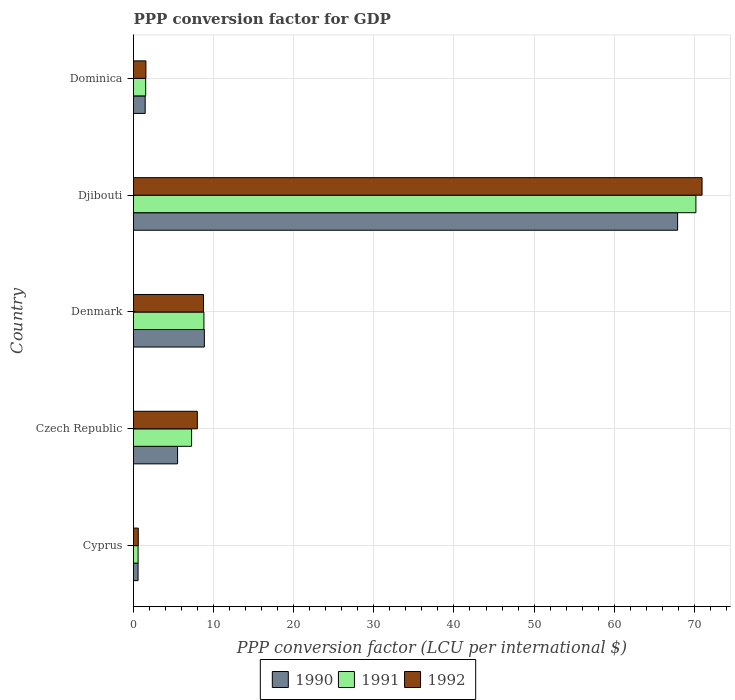How many groups of bars are there?
Offer a very short reply. 5. How many bars are there on the 1st tick from the top?
Offer a very short reply. 3. What is the label of the 1st group of bars from the top?
Make the answer very short. Dominica. In how many cases, is the number of bars for a given country not equal to the number of legend labels?
Make the answer very short. 0. What is the PPP conversion factor for GDP in 1992 in Denmark?
Provide a short and direct response. 8.74. Across all countries, what is the maximum PPP conversion factor for GDP in 1992?
Keep it short and to the point. 70.97. Across all countries, what is the minimum PPP conversion factor for GDP in 1990?
Your answer should be compact. 0.57. In which country was the PPP conversion factor for GDP in 1990 maximum?
Keep it short and to the point. Djibouti. In which country was the PPP conversion factor for GDP in 1992 minimum?
Give a very brief answer. Cyprus. What is the total PPP conversion factor for GDP in 1990 in the graph?
Give a very brief answer. 84.29. What is the difference between the PPP conversion factor for GDP in 1991 in Denmark and that in Dominica?
Offer a terse response. 7.27. What is the difference between the PPP conversion factor for GDP in 1990 in Denmark and the PPP conversion factor for GDP in 1991 in Djibouti?
Keep it short and to the point. -61.36. What is the average PPP conversion factor for GDP in 1991 per country?
Give a very brief answer. 17.67. What is the difference between the PPP conversion factor for GDP in 1990 and PPP conversion factor for GDP in 1991 in Czech Republic?
Provide a succinct answer. -1.75. In how many countries, is the PPP conversion factor for GDP in 1992 greater than 6 LCU?
Provide a short and direct response. 3. What is the ratio of the PPP conversion factor for GDP in 1990 in Cyprus to that in Djibouti?
Ensure brevity in your answer.  0.01. Is the PPP conversion factor for GDP in 1992 in Cyprus less than that in Denmark?
Your answer should be very brief. Yes. Is the difference between the PPP conversion factor for GDP in 1990 in Denmark and Dominica greater than the difference between the PPP conversion factor for GDP in 1991 in Denmark and Dominica?
Provide a succinct answer. Yes. What is the difference between the highest and the second highest PPP conversion factor for GDP in 1990?
Provide a short and direct response. 59.08. What is the difference between the highest and the lowest PPP conversion factor for GDP in 1991?
Your answer should be very brief. 69.63. Is the sum of the PPP conversion factor for GDP in 1992 in Czech Republic and Dominica greater than the maximum PPP conversion factor for GDP in 1990 across all countries?
Your answer should be compact. No. What does the 1st bar from the top in Dominica represents?
Provide a succinct answer. 1992. What does the 1st bar from the bottom in Cyprus represents?
Your response must be concise. 1990. Is it the case that in every country, the sum of the PPP conversion factor for GDP in 1990 and PPP conversion factor for GDP in 1991 is greater than the PPP conversion factor for GDP in 1992?
Keep it short and to the point. Yes. How many bars are there?
Give a very brief answer. 15. Are all the bars in the graph horizontal?
Provide a short and direct response. Yes. Where does the legend appear in the graph?
Give a very brief answer. Bottom center. How many legend labels are there?
Provide a succinct answer. 3. How are the legend labels stacked?
Your answer should be very brief. Horizontal. What is the title of the graph?
Make the answer very short. PPP conversion factor for GDP. Does "1972" appear as one of the legend labels in the graph?
Provide a succinct answer. No. What is the label or title of the X-axis?
Make the answer very short. PPP conversion factor (LCU per international $). What is the label or title of the Y-axis?
Offer a terse response. Country. What is the PPP conversion factor (LCU per international $) in 1990 in Cyprus?
Offer a terse response. 0.57. What is the PPP conversion factor (LCU per international $) of 1991 in Cyprus?
Make the answer very short. 0.57. What is the PPP conversion factor (LCU per international $) in 1992 in Cyprus?
Your answer should be very brief. 0.59. What is the PPP conversion factor (LCU per international $) of 1990 in Czech Republic?
Your answer should be compact. 5.5. What is the PPP conversion factor (LCU per international $) of 1991 in Czech Republic?
Offer a very short reply. 7.25. What is the PPP conversion factor (LCU per international $) in 1992 in Czech Republic?
Keep it short and to the point. 7.97. What is the PPP conversion factor (LCU per international $) of 1990 in Denmark?
Provide a short and direct response. 8.84. What is the PPP conversion factor (LCU per international $) of 1991 in Denmark?
Keep it short and to the point. 8.79. What is the PPP conversion factor (LCU per international $) in 1992 in Denmark?
Provide a short and direct response. 8.74. What is the PPP conversion factor (LCU per international $) in 1990 in Djibouti?
Give a very brief answer. 67.92. What is the PPP conversion factor (LCU per international $) of 1991 in Djibouti?
Give a very brief answer. 70.2. What is the PPP conversion factor (LCU per international $) of 1992 in Djibouti?
Keep it short and to the point. 70.97. What is the PPP conversion factor (LCU per international $) in 1990 in Dominica?
Your answer should be compact. 1.46. What is the PPP conversion factor (LCU per international $) of 1991 in Dominica?
Offer a very short reply. 1.52. What is the PPP conversion factor (LCU per international $) in 1992 in Dominica?
Your answer should be compact. 1.55. Across all countries, what is the maximum PPP conversion factor (LCU per international $) in 1990?
Offer a very short reply. 67.92. Across all countries, what is the maximum PPP conversion factor (LCU per international $) in 1991?
Offer a very short reply. 70.2. Across all countries, what is the maximum PPP conversion factor (LCU per international $) in 1992?
Your answer should be compact. 70.97. Across all countries, what is the minimum PPP conversion factor (LCU per international $) in 1990?
Provide a short and direct response. 0.57. Across all countries, what is the minimum PPP conversion factor (LCU per international $) in 1991?
Offer a terse response. 0.57. Across all countries, what is the minimum PPP conversion factor (LCU per international $) in 1992?
Ensure brevity in your answer.  0.59. What is the total PPP conversion factor (LCU per international $) in 1990 in the graph?
Provide a succinct answer. 84.29. What is the total PPP conversion factor (LCU per international $) in 1991 in the graph?
Make the answer very short. 88.34. What is the total PPP conversion factor (LCU per international $) of 1992 in the graph?
Your answer should be very brief. 89.82. What is the difference between the PPP conversion factor (LCU per international $) of 1990 in Cyprus and that in Czech Republic?
Your answer should be very brief. -4.93. What is the difference between the PPP conversion factor (LCU per international $) in 1991 in Cyprus and that in Czech Republic?
Offer a very short reply. -6.68. What is the difference between the PPP conversion factor (LCU per international $) in 1992 in Cyprus and that in Czech Republic?
Your answer should be compact. -7.37. What is the difference between the PPP conversion factor (LCU per international $) in 1990 in Cyprus and that in Denmark?
Give a very brief answer. -8.27. What is the difference between the PPP conversion factor (LCU per international $) in 1991 in Cyprus and that in Denmark?
Provide a succinct answer. -8.22. What is the difference between the PPP conversion factor (LCU per international $) in 1992 in Cyprus and that in Denmark?
Keep it short and to the point. -8.14. What is the difference between the PPP conversion factor (LCU per international $) in 1990 in Cyprus and that in Djibouti?
Offer a very short reply. -67.35. What is the difference between the PPP conversion factor (LCU per international $) in 1991 in Cyprus and that in Djibouti?
Provide a short and direct response. -69.63. What is the difference between the PPP conversion factor (LCU per international $) of 1992 in Cyprus and that in Djibouti?
Provide a succinct answer. -70.38. What is the difference between the PPP conversion factor (LCU per international $) in 1990 in Cyprus and that in Dominica?
Your response must be concise. -0.89. What is the difference between the PPP conversion factor (LCU per international $) in 1991 in Cyprus and that in Dominica?
Your response must be concise. -0.95. What is the difference between the PPP conversion factor (LCU per international $) of 1992 in Cyprus and that in Dominica?
Give a very brief answer. -0.95. What is the difference between the PPP conversion factor (LCU per international $) in 1990 in Czech Republic and that in Denmark?
Offer a terse response. -3.34. What is the difference between the PPP conversion factor (LCU per international $) of 1991 in Czech Republic and that in Denmark?
Make the answer very short. -1.54. What is the difference between the PPP conversion factor (LCU per international $) in 1992 in Czech Republic and that in Denmark?
Keep it short and to the point. -0.77. What is the difference between the PPP conversion factor (LCU per international $) in 1990 in Czech Republic and that in Djibouti?
Give a very brief answer. -62.42. What is the difference between the PPP conversion factor (LCU per international $) of 1991 in Czech Republic and that in Djibouti?
Your response must be concise. -62.95. What is the difference between the PPP conversion factor (LCU per international $) in 1992 in Czech Republic and that in Djibouti?
Your answer should be very brief. -63. What is the difference between the PPP conversion factor (LCU per international $) in 1990 in Czech Republic and that in Dominica?
Give a very brief answer. 4.04. What is the difference between the PPP conversion factor (LCU per international $) in 1991 in Czech Republic and that in Dominica?
Your answer should be compact. 5.73. What is the difference between the PPP conversion factor (LCU per international $) of 1992 in Czech Republic and that in Dominica?
Your answer should be compact. 6.42. What is the difference between the PPP conversion factor (LCU per international $) of 1990 in Denmark and that in Djibouti?
Your response must be concise. -59.08. What is the difference between the PPP conversion factor (LCU per international $) in 1991 in Denmark and that in Djibouti?
Your response must be concise. -61.41. What is the difference between the PPP conversion factor (LCU per international $) in 1992 in Denmark and that in Djibouti?
Make the answer very short. -62.23. What is the difference between the PPP conversion factor (LCU per international $) of 1990 in Denmark and that in Dominica?
Keep it short and to the point. 7.39. What is the difference between the PPP conversion factor (LCU per international $) of 1991 in Denmark and that in Dominica?
Offer a terse response. 7.27. What is the difference between the PPP conversion factor (LCU per international $) in 1992 in Denmark and that in Dominica?
Your answer should be compact. 7.19. What is the difference between the PPP conversion factor (LCU per international $) in 1990 in Djibouti and that in Dominica?
Make the answer very short. 66.46. What is the difference between the PPP conversion factor (LCU per international $) of 1991 in Djibouti and that in Dominica?
Your answer should be compact. 68.68. What is the difference between the PPP conversion factor (LCU per international $) in 1992 in Djibouti and that in Dominica?
Your answer should be compact. 69.42. What is the difference between the PPP conversion factor (LCU per international $) in 1990 in Cyprus and the PPP conversion factor (LCU per international $) in 1991 in Czech Republic?
Keep it short and to the point. -6.68. What is the difference between the PPP conversion factor (LCU per international $) of 1990 in Cyprus and the PPP conversion factor (LCU per international $) of 1992 in Czech Republic?
Offer a terse response. -7.4. What is the difference between the PPP conversion factor (LCU per international $) in 1991 in Cyprus and the PPP conversion factor (LCU per international $) in 1992 in Czech Republic?
Provide a succinct answer. -7.39. What is the difference between the PPP conversion factor (LCU per international $) in 1990 in Cyprus and the PPP conversion factor (LCU per international $) in 1991 in Denmark?
Offer a terse response. -8.22. What is the difference between the PPP conversion factor (LCU per international $) in 1990 in Cyprus and the PPP conversion factor (LCU per international $) in 1992 in Denmark?
Your response must be concise. -8.17. What is the difference between the PPP conversion factor (LCU per international $) in 1991 in Cyprus and the PPP conversion factor (LCU per international $) in 1992 in Denmark?
Your answer should be very brief. -8.16. What is the difference between the PPP conversion factor (LCU per international $) of 1990 in Cyprus and the PPP conversion factor (LCU per international $) of 1991 in Djibouti?
Provide a short and direct response. -69.63. What is the difference between the PPP conversion factor (LCU per international $) of 1990 in Cyprus and the PPP conversion factor (LCU per international $) of 1992 in Djibouti?
Your answer should be compact. -70.4. What is the difference between the PPP conversion factor (LCU per international $) of 1991 in Cyprus and the PPP conversion factor (LCU per international $) of 1992 in Djibouti?
Provide a succinct answer. -70.4. What is the difference between the PPP conversion factor (LCU per international $) of 1990 in Cyprus and the PPP conversion factor (LCU per international $) of 1991 in Dominica?
Your answer should be very brief. -0.95. What is the difference between the PPP conversion factor (LCU per international $) in 1990 in Cyprus and the PPP conversion factor (LCU per international $) in 1992 in Dominica?
Your answer should be compact. -0.98. What is the difference between the PPP conversion factor (LCU per international $) in 1991 in Cyprus and the PPP conversion factor (LCU per international $) in 1992 in Dominica?
Provide a succinct answer. -0.97. What is the difference between the PPP conversion factor (LCU per international $) of 1990 in Czech Republic and the PPP conversion factor (LCU per international $) of 1991 in Denmark?
Ensure brevity in your answer.  -3.29. What is the difference between the PPP conversion factor (LCU per international $) of 1990 in Czech Republic and the PPP conversion factor (LCU per international $) of 1992 in Denmark?
Provide a short and direct response. -3.24. What is the difference between the PPP conversion factor (LCU per international $) in 1991 in Czech Republic and the PPP conversion factor (LCU per international $) in 1992 in Denmark?
Provide a succinct answer. -1.49. What is the difference between the PPP conversion factor (LCU per international $) in 1990 in Czech Republic and the PPP conversion factor (LCU per international $) in 1991 in Djibouti?
Offer a very short reply. -64.7. What is the difference between the PPP conversion factor (LCU per international $) of 1990 in Czech Republic and the PPP conversion factor (LCU per international $) of 1992 in Djibouti?
Your answer should be compact. -65.47. What is the difference between the PPP conversion factor (LCU per international $) in 1991 in Czech Republic and the PPP conversion factor (LCU per international $) in 1992 in Djibouti?
Your answer should be very brief. -63.72. What is the difference between the PPP conversion factor (LCU per international $) of 1990 in Czech Republic and the PPP conversion factor (LCU per international $) of 1991 in Dominica?
Provide a succinct answer. 3.98. What is the difference between the PPP conversion factor (LCU per international $) of 1990 in Czech Republic and the PPP conversion factor (LCU per international $) of 1992 in Dominica?
Make the answer very short. 3.95. What is the difference between the PPP conversion factor (LCU per international $) of 1991 in Czech Republic and the PPP conversion factor (LCU per international $) of 1992 in Dominica?
Make the answer very short. 5.7. What is the difference between the PPP conversion factor (LCU per international $) of 1990 in Denmark and the PPP conversion factor (LCU per international $) of 1991 in Djibouti?
Offer a terse response. -61.36. What is the difference between the PPP conversion factor (LCU per international $) of 1990 in Denmark and the PPP conversion factor (LCU per international $) of 1992 in Djibouti?
Give a very brief answer. -62.13. What is the difference between the PPP conversion factor (LCU per international $) of 1991 in Denmark and the PPP conversion factor (LCU per international $) of 1992 in Djibouti?
Provide a succinct answer. -62.18. What is the difference between the PPP conversion factor (LCU per international $) in 1990 in Denmark and the PPP conversion factor (LCU per international $) in 1991 in Dominica?
Your response must be concise. 7.32. What is the difference between the PPP conversion factor (LCU per international $) in 1990 in Denmark and the PPP conversion factor (LCU per international $) in 1992 in Dominica?
Give a very brief answer. 7.3. What is the difference between the PPP conversion factor (LCU per international $) of 1991 in Denmark and the PPP conversion factor (LCU per international $) of 1992 in Dominica?
Provide a succinct answer. 7.24. What is the difference between the PPP conversion factor (LCU per international $) in 1990 in Djibouti and the PPP conversion factor (LCU per international $) in 1991 in Dominica?
Make the answer very short. 66.4. What is the difference between the PPP conversion factor (LCU per international $) of 1990 in Djibouti and the PPP conversion factor (LCU per international $) of 1992 in Dominica?
Ensure brevity in your answer.  66.37. What is the difference between the PPP conversion factor (LCU per international $) in 1991 in Djibouti and the PPP conversion factor (LCU per international $) in 1992 in Dominica?
Give a very brief answer. 68.65. What is the average PPP conversion factor (LCU per international $) in 1990 per country?
Your answer should be compact. 16.86. What is the average PPP conversion factor (LCU per international $) of 1991 per country?
Make the answer very short. 17.67. What is the average PPP conversion factor (LCU per international $) in 1992 per country?
Make the answer very short. 17.96. What is the difference between the PPP conversion factor (LCU per international $) in 1990 and PPP conversion factor (LCU per international $) in 1991 in Cyprus?
Provide a succinct answer. -0. What is the difference between the PPP conversion factor (LCU per international $) of 1990 and PPP conversion factor (LCU per international $) of 1992 in Cyprus?
Your response must be concise. -0.02. What is the difference between the PPP conversion factor (LCU per international $) of 1991 and PPP conversion factor (LCU per international $) of 1992 in Cyprus?
Your response must be concise. -0.02. What is the difference between the PPP conversion factor (LCU per international $) in 1990 and PPP conversion factor (LCU per international $) in 1991 in Czech Republic?
Make the answer very short. -1.75. What is the difference between the PPP conversion factor (LCU per international $) of 1990 and PPP conversion factor (LCU per international $) of 1992 in Czech Republic?
Give a very brief answer. -2.46. What is the difference between the PPP conversion factor (LCU per international $) of 1991 and PPP conversion factor (LCU per international $) of 1992 in Czech Republic?
Offer a very short reply. -0.71. What is the difference between the PPP conversion factor (LCU per international $) of 1990 and PPP conversion factor (LCU per international $) of 1991 in Denmark?
Provide a succinct answer. 0.06. What is the difference between the PPP conversion factor (LCU per international $) of 1990 and PPP conversion factor (LCU per international $) of 1992 in Denmark?
Offer a terse response. 0.11. What is the difference between the PPP conversion factor (LCU per international $) in 1991 and PPP conversion factor (LCU per international $) in 1992 in Denmark?
Keep it short and to the point. 0.05. What is the difference between the PPP conversion factor (LCU per international $) of 1990 and PPP conversion factor (LCU per international $) of 1991 in Djibouti?
Your answer should be very brief. -2.28. What is the difference between the PPP conversion factor (LCU per international $) in 1990 and PPP conversion factor (LCU per international $) in 1992 in Djibouti?
Your answer should be very brief. -3.05. What is the difference between the PPP conversion factor (LCU per international $) of 1991 and PPP conversion factor (LCU per international $) of 1992 in Djibouti?
Provide a succinct answer. -0.77. What is the difference between the PPP conversion factor (LCU per international $) of 1990 and PPP conversion factor (LCU per international $) of 1991 in Dominica?
Ensure brevity in your answer.  -0.06. What is the difference between the PPP conversion factor (LCU per international $) in 1990 and PPP conversion factor (LCU per international $) in 1992 in Dominica?
Your answer should be very brief. -0.09. What is the difference between the PPP conversion factor (LCU per international $) of 1991 and PPP conversion factor (LCU per international $) of 1992 in Dominica?
Keep it short and to the point. -0.03. What is the ratio of the PPP conversion factor (LCU per international $) of 1990 in Cyprus to that in Czech Republic?
Give a very brief answer. 0.1. What is the ratio of the PPP conversion factor (LCU per international $) of 1991 in Cyprus to that in Czech Republic?
Offer a terse response. 0.08. What is the ratio of the PPP conversion factor (LCU per international $) of 1992 in Cyprus to that in Czech Republic?
Provide a short and direct response. 0.07. What is the ratio of the PPP conversion factor (LCU per international $) of 1990 in Cyprus to that in Denmark?
Ensure brevity in your answer.  0.06. What is the ratio of the PPP conversion factor (LCU per international $) of 1991 in Cyprus to that in Denmark?
Make the answer very short. 0.07. What is the ratio of the PPP conversion factor (LCU per international $) in 1992 in Cyprus to that in Denmark?
Provide a short and direct response. 0.07. What is the ratio of the PPP conversion factor (LCU per international $) in 1990 in Cyprus to that in Djibouti?
Give a very brief answer. 0.01. What is the ratio of the PPP conversion factor (LCU per international $) in 1991 in Cyprus to that in Djibouti?
Make the answer very short. 0.01. What is the ratio of the PPP conversion factor (LCU per international $) in 1992 in Cyprus to that in Djibouti?
Provide a succinct answer. 0.01. What is the ratio of the PPP conversion factor (LCU per international $) in 1990 in Cyprus to that in Dominica?
Provide a succinct answer. 0.39. What is the ratio of the PPP conversion factor (LCU per international $) in 1991 in Cyprus to that in Dominica?
Provide a short and direct response. 0.38. What is the ratio of the PPP conversion factor (LCU per international $) in 1992 in Cyprus to that in Dominica?
Your answer should be compact. 0.38. What is the ratio of the PPP conversion factor (LCU per international $) in 1990 in Czech Republic to that in Denmark?
Offer a terse response. 0.62. What is the ratio of the PPP conversion factor (LCU per international $) in 1991 in Czech Republic to that in Denmark?
Provide a succinct answer. 0.83. What is the ratio of the PPP conversion factor (LCU per international $) in 1992 in Czech Republic to that in Denmark?
Ensure brevity in your answer.  0.91. What is the ratio of the PPP conversion factor (LCU per international $) in 1990 in Czech Republic to that in Djibouti?
Make the answer very short. 0.08. What is the ratio of the PPP conversion factor (LCU per international $) in 1991 in Czech Republic to that in Djibouti?
Ensure brevity in your answer.  0.1. What is the ratio of the PPP conversion factor (LCU per international $) of 1992 in Czech Republic to that in Djibouti?
Make the answer very short. 0.11. What is the ratio of the PPP conversion factor (LCU per international $) in 1990 in Czech Republic to that in Dominica?
Your answer should be very brief. 3.78. What is the ratio of the PPP conversion factor (LCU per international $) of 1991 in Czech Republic to that in Dominica?
Provide a short and direct response. 4.77. What is the ratio of the PPP conversion factor (LCU per international $) of 1992 in Czech Republic to that in Dominica?
Your answer should be very brief. 5.14. What is the ratio of the PPP conversion factor (LCU per international $) in 1990 in Denmark to that in Djibouti?
Make the answer very short. 0.13. What is the ratio of the PPP conversion factor (LCU per international $) in 1991 in Denmark to that in Djibouti?
Your answer should be very brief. 0.13. What is the ratio of the PPP conversion factor (LCU per international $) of 1992 in Denmark to that in Djibouti?
Provide a succinct answer. 0.12. What is the ratio of the PPP conversion factor (LCU per international $) of 1990 in Denmark to that in Dominica?
Provide a succinct answer. 6.07. What is the ratio of the PPP conversion factor (LCU per international $) of 1991 in Denmark to that in Dominica?
Your answer should be compact. 5.78. What is the ratio of the PPP conversion factor (LCU per international $) in 1992 in Denmark to that in Dominica?
Your answer should be compact. 5.64. What is the ratio of the PPP conversion factor (LCU per international $) of 1990 in Djibouti to that in Dominica?
Your response must be concise. 46.61. What is the ratio of the PPP conversion factor (LCU per international $) of 1991 in Djibouti to that in Dominica?
Your answer should be compact. 46.16. What is the ratio of the PPP conversion factor (LCU per international $) in 1992 in Djibouti to that in Dominica?
Keep it short and to the point. 45.84. What is the difference between the highest and the second highest PPP conversion factor (LCU per international $) of 1990?
Ensure brevity in your answer.  59.08. What is the difference between the highest and the second highest PPP conversion factor (LCU per international $) of 1991?
Give a very brief answer. 61.41. What is the difference between the highest and the second highest PPP conversion factor (LCU per international $) in 1992?
Offer a very short reply. 62.23. What is the difference between the highest and the lowest PPP conversion factor (LCU per international $) of 1990?
Offer a terse response. 67.35. What is the difference between the highest and the lowest PPP conversion factor (LCU per international $) in 1991?
Provide a succinct answer. 69.63. What is the difference between the highest and the lowest PPP conversion factor (LCU per international $) of 1992?
Offer a terse response. 70.38. 